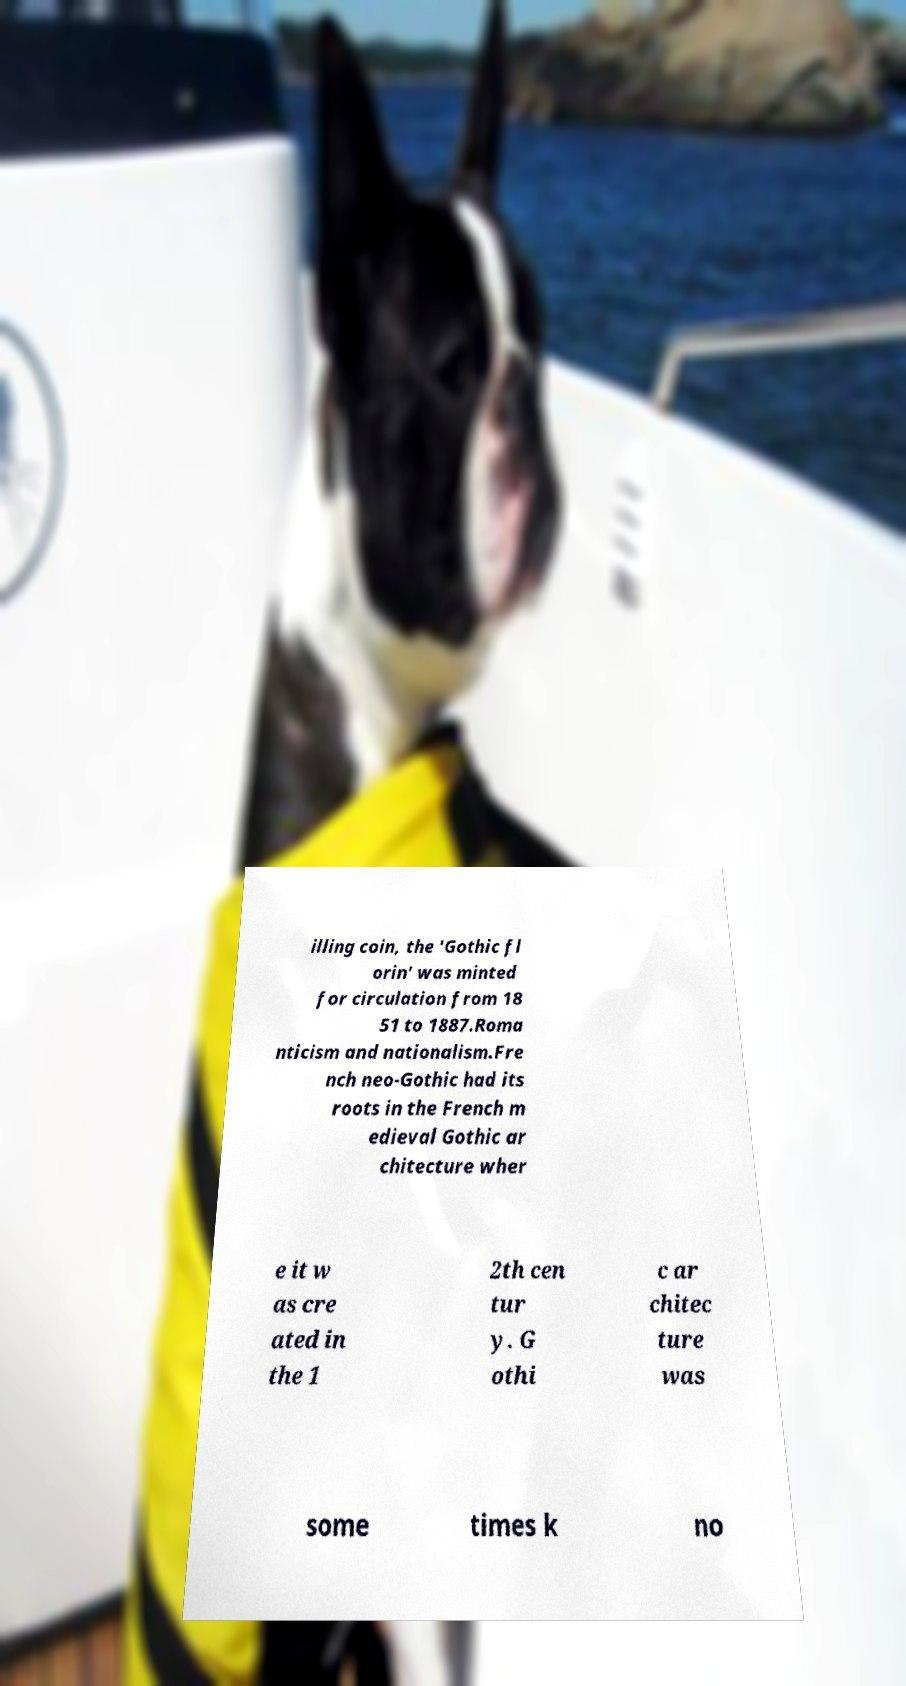There's text embedded in this image that I need extracted. Can you transcribe it verbatim? illing coin, the 'Gothic fl orin' was minted for circulation from 18 51 to 1887.Roma nticism and nationalism.Fre nch neo-Gothic had its roots in the French m edieval Gothic ar chitecture wher e it w as cre ated in the 1 2th cen tur y. G othi c ar chitec ture was some times k no 